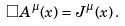Convert formula to latex. <formula><loc_0><loc_0><loc_500><loc_500>\Box A ^ { \mu } ( x ) = J ^ { \mu } ( x ) \, .</formula> 